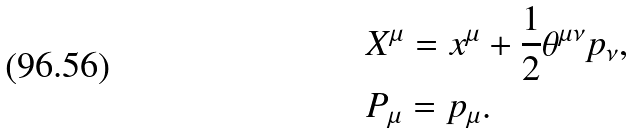Convert formula to latex. <formula><loc_0><loc_0><loc_500><loc_500>& X ^ { \mu } = x ^ { \mu } + \frac { 1 } { 2 } \theta ^ { \mu \nu } p _ { \nu } , \\ & P _ { \mu } = p _ { \mu } .</formula> 